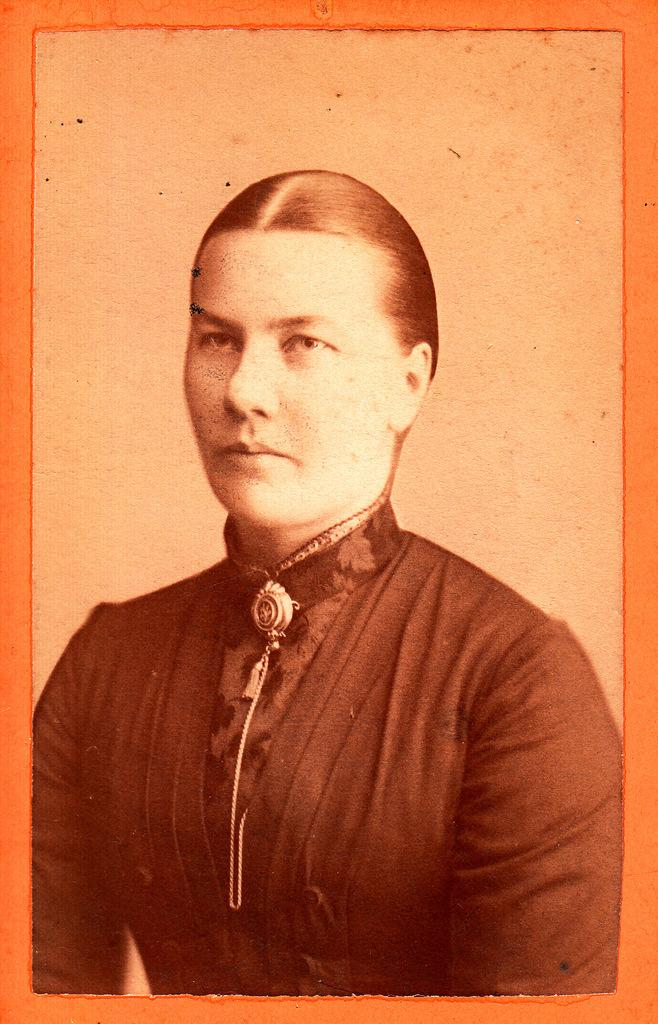What is the main subject of the image? There is a picture of a woman in the image. What is the woman wearing in the image? The woman is wearing a black dress. What type of comfort can be found in the image? The image does not depict any comfort or comfort-related objects. What flavor of ice cream is the woman eating in the image? There is no ice cream present in the image, so it is not possible to determine the flavor. 